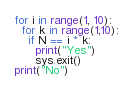Convert code to text. <code><loc_0><loc_0><loc_500><loc_500><_Python_>for i in range(1, 10):
  for k in range(1,10):
    if N == i * k:
      print("Yes")
      sys.exit()
print("No")</code> 